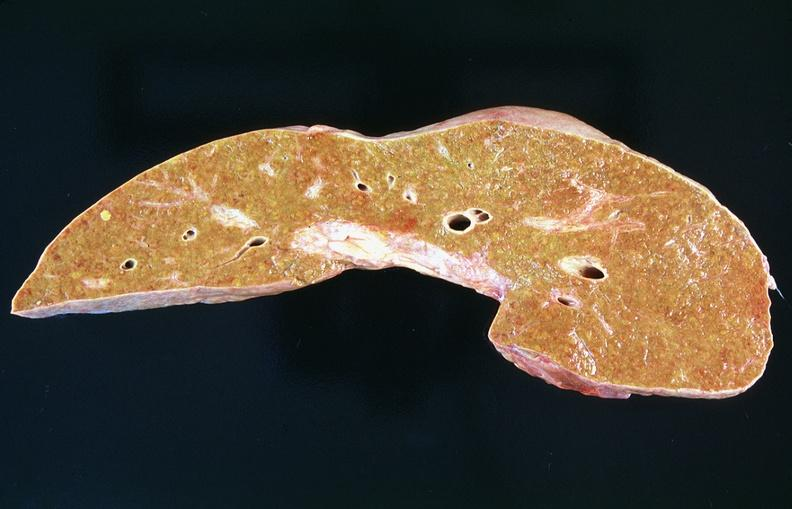what is present?
Answer the question using a single word or phrase. Hepatobiliary 